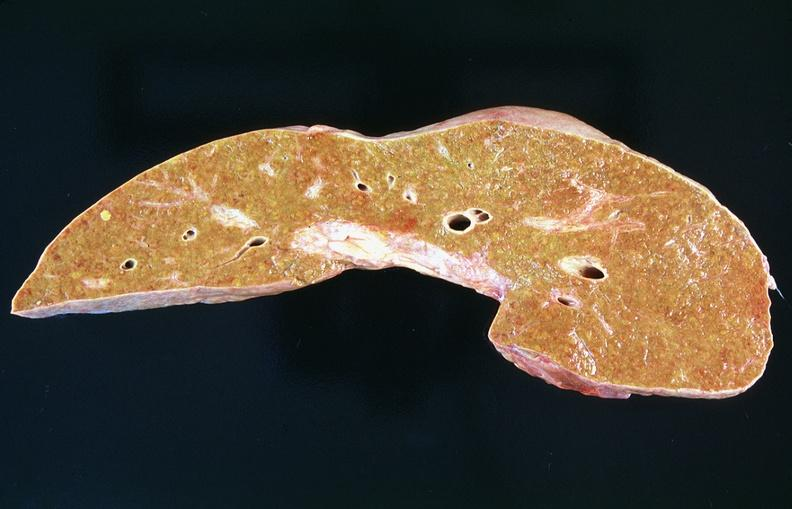what is present?
Answer the question using a single word or phrase. Hepatobiliary 